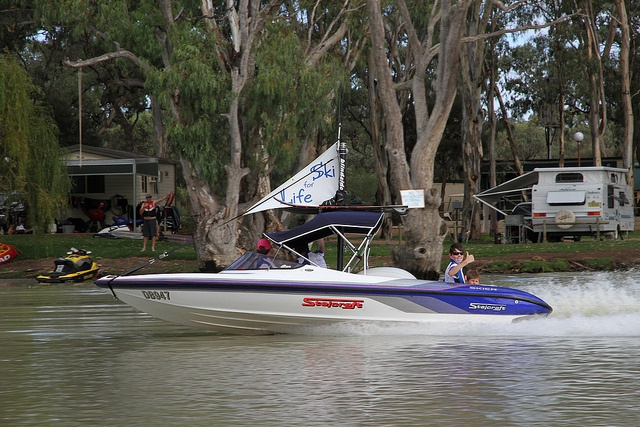Describe the objects in this image and their specific colors. I can see boat in black, lightgray, gray, and darkgray tones, boat in black, olive, gray, and orange tones, people in black, maroon, and brown tones, people in black, brown, tan, and darkgray tones, and people in black, gray, and maroon tones in this image. 